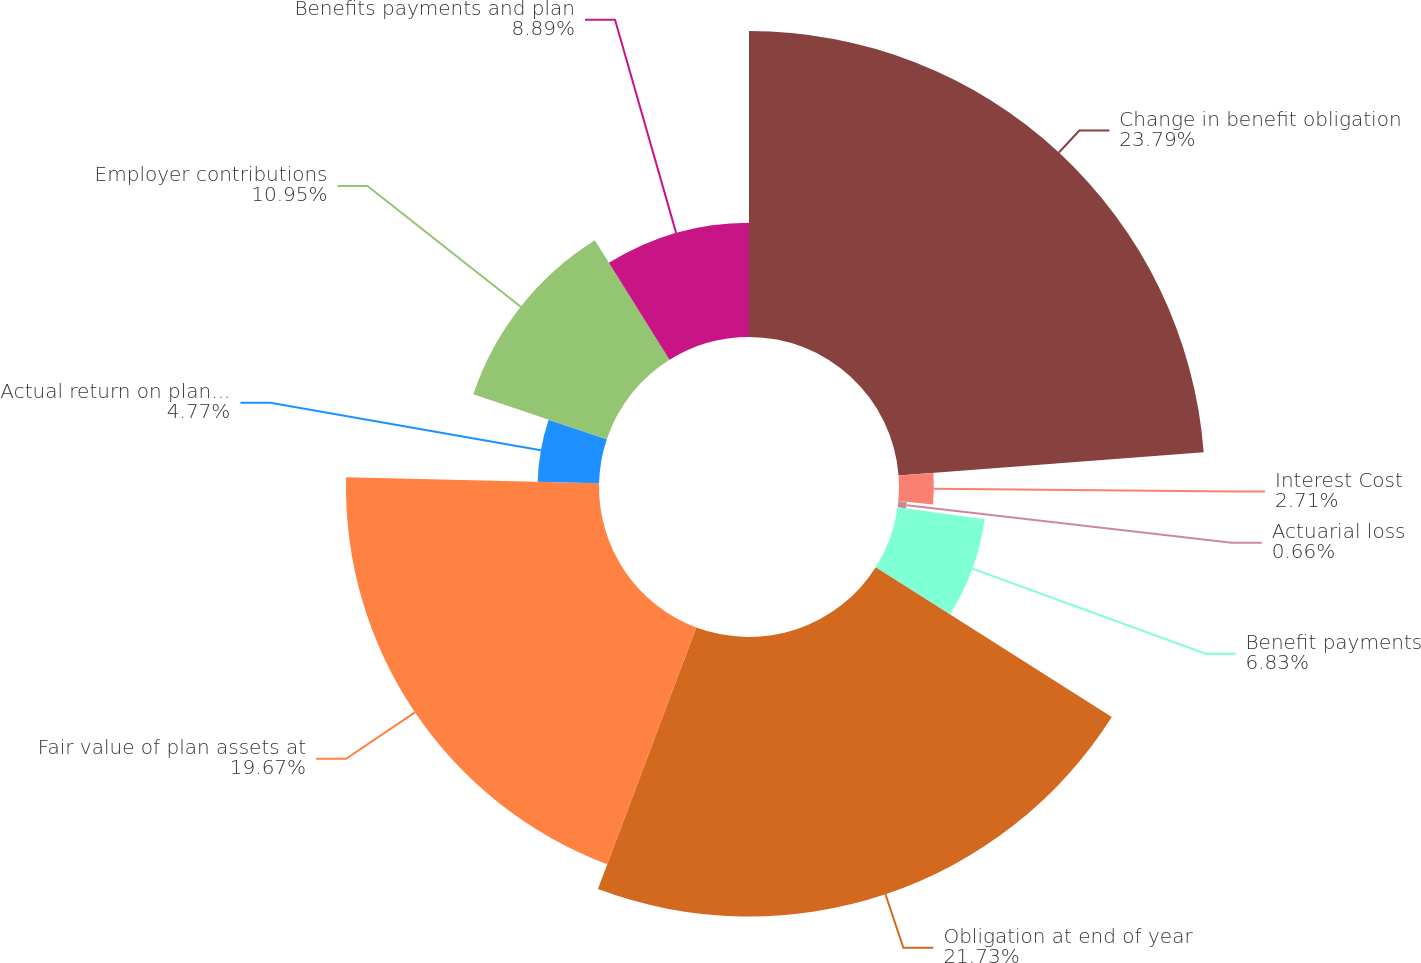Convert chart. <chart><loc_0><loc_0><loc_500><loc_500><pie_chart><fcel>Change in benefit obligation<fcel>Interest Cost<fcel>Actuarial loss<fcel>Benefit payments<fcel>Obligation at end of year<fcel>Fair value of plan assets at<fcel>Actual return on plan assets<fcel>Employer contributions<fcel>Benefits payments and plan<nl><fcel>23.79%<fcel>2.71%<fcel>0.66%<fcel>6.83%<fcel>21.73%<fcel>19.67%<fcel>4.77%<fcel>10.95%<fcel>8.89%<nl></chart> 